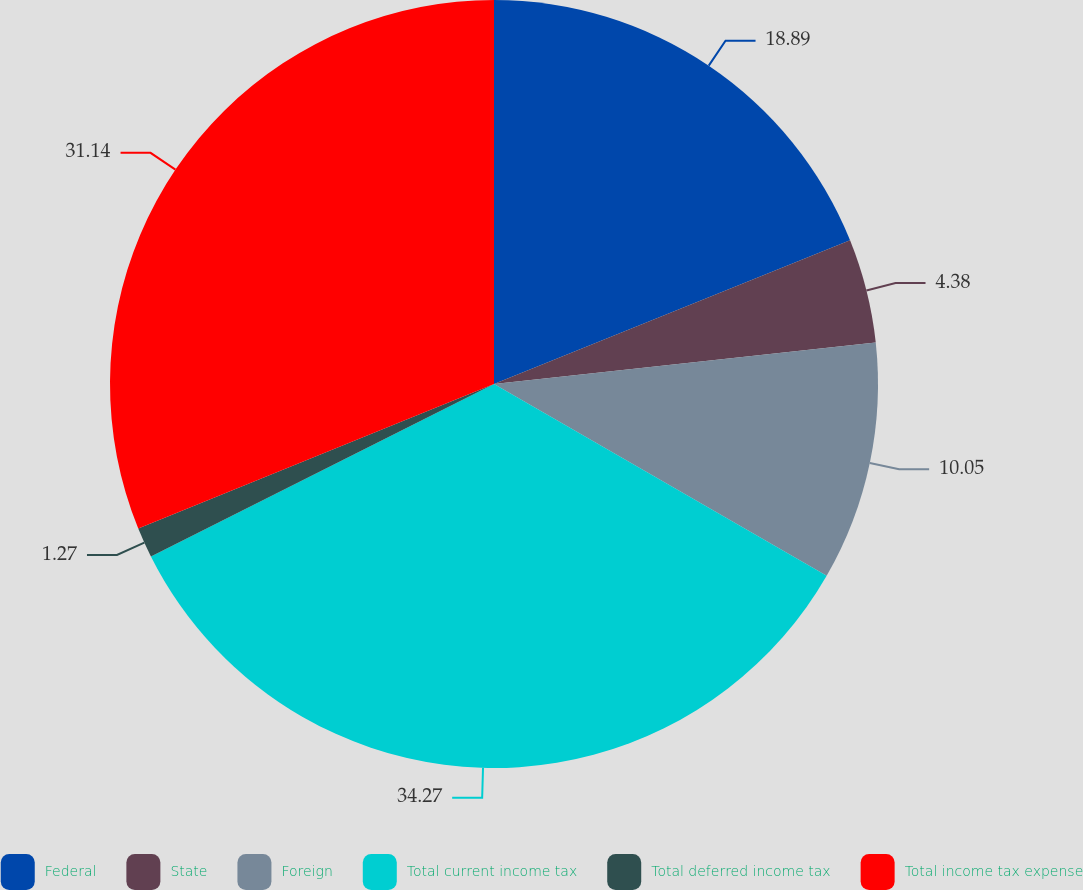<chart> <loc_0><loc_0><loc_500><loc_500><pie_chart><fcel>Federal<fcel>State<fcel>Foreign<fcel>Total current income tax<fcel>Total deferred income tax<fcel>Total income tax expense<nl><fcel>18.89%<fcel>4.38%<fcel>10.05%<fcel>34.26%<fcel>1.27%<fcel>31.14%<nl></chart> 